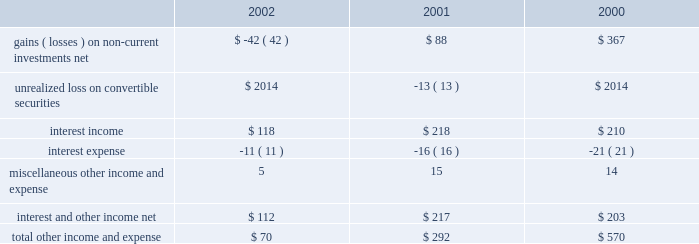Other income and expense for the three fiscal years ended september 28 , 2002 are as follows ( in millions ) : gains and losses on non-current investments investments categorized as non-current debt and equity investments on the consolidated balance sheet are in equity and debt instruments of public companies .
The company's non-current debt and equity investments , and certain investments in private companies carried in other assets , have been categorized as available-for-sale requiring that they be carried at fair value with unrealized gains and losses , net of taxes , reported in equity as a component of accumulated other comprehensive income .
However , the company recognizes an impairment charge to earnings in the event a decline in fair value below the cost basis of one of these investments is determined to be other-than-temporary .
The company includes recognized gains and losses resulting from the sale or from other-than-temporary declines in fair value associated with these investments in other income and expense .
Further information related to the company's non-current debt and equity investments may be found in part ii , item 8 of this form 10-k at note 2 of notes to consolidated financial statements .
During 2002 , the company determined that declines in the fair value of certain of these investments were other-than-temporary .
As a result , the company recognized a $ 44 million charge to earnings to write-down the basis of its investment in earthlink , inc .
( earthlink ) , a $ 6 million charge to earnings to write-down the basis of its investment in akamai technologies , inc .
( akamai ) , and a $ 15 million charge to earnings to write-down the basis of its investment in a private company investment .
These losses in 2002 were partially offset by the sale of 117000 shares of earthlink stock for net proceeds of $ 2 million and a gain before taxes of $ 223000 , the sale of 250000 shares of akamai stock for net proceeds of $ 2 million and a gain before taxes of $ 710000 , and the sale of approximately 4.7 million shares of arm holdings plc ( arm ) stock for both net proceeds and a gain before taxes of $ 21 million .
During 2001 , the company sold a total of approximately 1 million shares of akamai stock for net proceeds of $ 39 million and recorded a gain before taxes of $ 36 million , and sold a total of approximately 29.8 million shares of arm stock for net proceeds of $ 176 million and recorded a gain before taxes of $ 174 million .
These gains during 2001 were partially offset by a $ 114 million charge to earnings that reflected an other- than-temporary decline in the fair value of the company's investment in earthlink and an $ 8 million charge that reflected an other-than- temporary decline in the fair value of certain private company investments .
During 2000 , the company sold a total of approximately 45.2 million shares of arm stock for net proceeds of $ 372 million and a gain before taxes of $ 367 million .
The combined carrying value of the company's investments in earthlink , akamai , and arm as of september 28 , 2002 , was $ 39 million .
The company believes it is likely there will continue to be significant fluctuations in the fair value of these investments in the future .
Accounting for derivatives and cumulative effect of accounting change on october 1 , 2000 , the company adopted statement of financial accounting standard ( sfas ) no .
133 , accounting for derivative instruments and hedging activities .
Sfas no .
133 established accounting and reporting standards for derivative instruments , hedging activities , and exposure definition .
Net of the related income tax effect of approximately $ 5 million , adoption of sfas no .
133 resulted in a favorable cumulative-effect-type adjustment to net income of approximately $ 12 million for the first quarter of 2001 .
The $ 17 million gross transition adjustment was comprised of a $ 23 million favorable adjustment for the restatement to fair value of the derivative component of the company's investment in samsung electronics co. , ltd .
( samsung ) , partially offset by the unfavorable adjustments to certain foreign currency and interest rate derivatives .
Sfas no .
133 also required the company to adjust the carrying value of the derivative component of its investment in samsung to earnings during the first quarter of 2001 , the before tax effect of which was an unrealized loss of approximately $ 13 million .
Interest and other income , net net interest and other income was $ 112 million in fiscal 2002 , compared to $ 217 million in fiscal 2001 .
This $ 105 million or 48% ( 48 % ) decrease is .
Total other income and expense .
What was the change in millions of total other income and expense from 2000 to 2001? 
Computations: (292 - 570)
Answer: -278.0. Other income and expense for the three fiscal years ended september 28 , 2002 are as follows ( in millions ) : gains and losses on non-current investments investments categorized as non-current debt and equity investments on the consolidated balance sheet are in equity and debt instruments of public companies .
The company's non-current debt and equity investments , and certain investments in private companies carried in other assets , have been categorized as available-for-sale requiring that they be carried at fair value with unrealized gains and losses , net of taxes , reported in equity as a component of accumulated other comprehensive income .
However , the company recognizes an impairment charge to earnings in the event a decline in fair value below the cost basis of one of these investments is determined to be other-than-temporary .
The company includes recognized gains and losses resulting from the sale or from other-than-temporary declines in fair value associated with these investments in other income and expense .
Further information related to the company's non-current debt and equity investments may be found in part ii , item 8 of this form 10-k at note 2 of notes to consolidated financial statements .
During 2002 , the company determined that declines in the fair value of certain of these investments were other-than-temporary .
As a result , the company recognized a $ 44 million charge to earnings to write-down the basis of its investment in earthlink , inc .
( earthlink ) , a $ 6 million charge to earnings to write-down the basis of its investment in akamai technologies , inc .
( akamai ) , and a $ 15 million charge to earnings to write-down the basis of its investment in a private company investment .
These losses in 2002 were partially offset by the sale of 117000 shares of earthlink stock for net proceeds of $ 2 million and a gain before taxes of $ 223000 , the sale of 250000 shares of akamai stock for net proceeds of $ 2 million and a gain before taxes of $ 710000 , and the sale of approximately 4.7 million shares of arm holdings plc ( arm ) stock for both net proceeds and a gain before taxes of $ 21 million .
During 2001 , the company sold a total of approximately 1 million shares of akamai stock for net proceeds of $ 39 million and recorded a gain before taxes of $ 36 million , and sold a total of approximately 29.8 million shares of arm stock for net proceeds of $ 176 million and recorded a gain before taxes of $ 174 million .
These gains during 2001 were partially offset by a $ 114 million charge to earnings that reflected an other- than-temporary decline in the fair value of the company's investment in earthlink and an $ 8 million charge that reflected an other-than- temporary decline in the fair value of certain private company investments .
During 2000 , the company sold a total of approximately 45.2 million shares of arm stock for net proceeds of $ 372 million and a gain before taxes of $ 367 million .
The combined carrying value of the company's investments in earthlink , akamai , and arm as of september 28 , 2002 , was $ 39 million .
The company believes it is likely there will continue to be significant fluctuations in the fair value of these investments in the future .
Accounting for derivatives and cumulative effect of accounting change on october 1 , 2000 , the company adopted statement of financial accounting standard ( sfas ) no .
133 , accounting for derivative instruments and hedging activities .
Sfas no .
133 established accounting and reporting standards for derivative instruments , hedging activities , and exposure definition .
Net of the related income tax effect of approximately $ 5 million , adoption of sfas no .
133 resulted in a favorable cumulative-effect-type adjustment to net income of approximately $ 12 million for the first quarter of 2001 .
The $ 17 million gross transition adjustment was comprised of a $ 23 million favorable adjustment for the restatement to fair value of the derivative component of the company's investment in samsung electronics co. , ltd .
( samsung ) , partially offset by the unfavorable adjustments to certain foreign currency and interest rate derivatives .
Sfas no .
133 also required the company to adjust the carrying value of the derivative component of its investment in samsung to earnings during the first quarter of 2001 , the before tax effect of which was an unrealized loss of approximately $ 13 million .
Interest and other income , net net interest and other income was $ 112 million in fiscal 2002 , compared to $ 217 million in fiscal 2001 .
This $ 105 million or 48% ( 48 % ) decrease is .
Total other income and expense .
What was gross transition adjustment without the $ 23 million favorable adjustment for the restatement to fair value of the derivative component of the company's investment in samsung electronics co . , ltd , in millions? 
Computations: (17 - 23)
Answer: -6.0. 